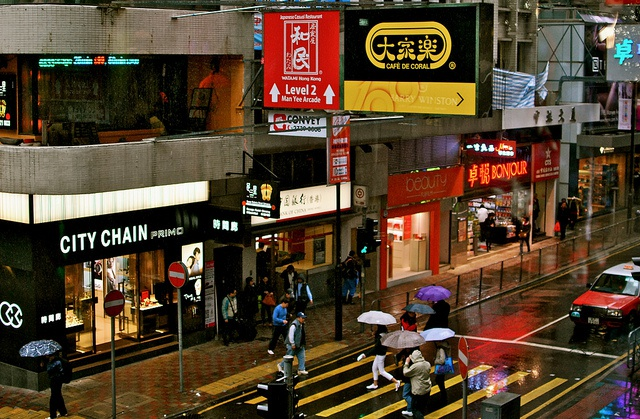Describe the objects in this image and their specific colors. I can see people in darkgreen, black, maroon, and gray tones, car in darkgreen, black, red, lavender, and darkgray tones, people in darkgreen, black, gray, and darkgray tones, people in darkgreen, black, gray, blue, and lavender tones, and people in darkgreen, black, lavender, and darkgray tones in this image. 